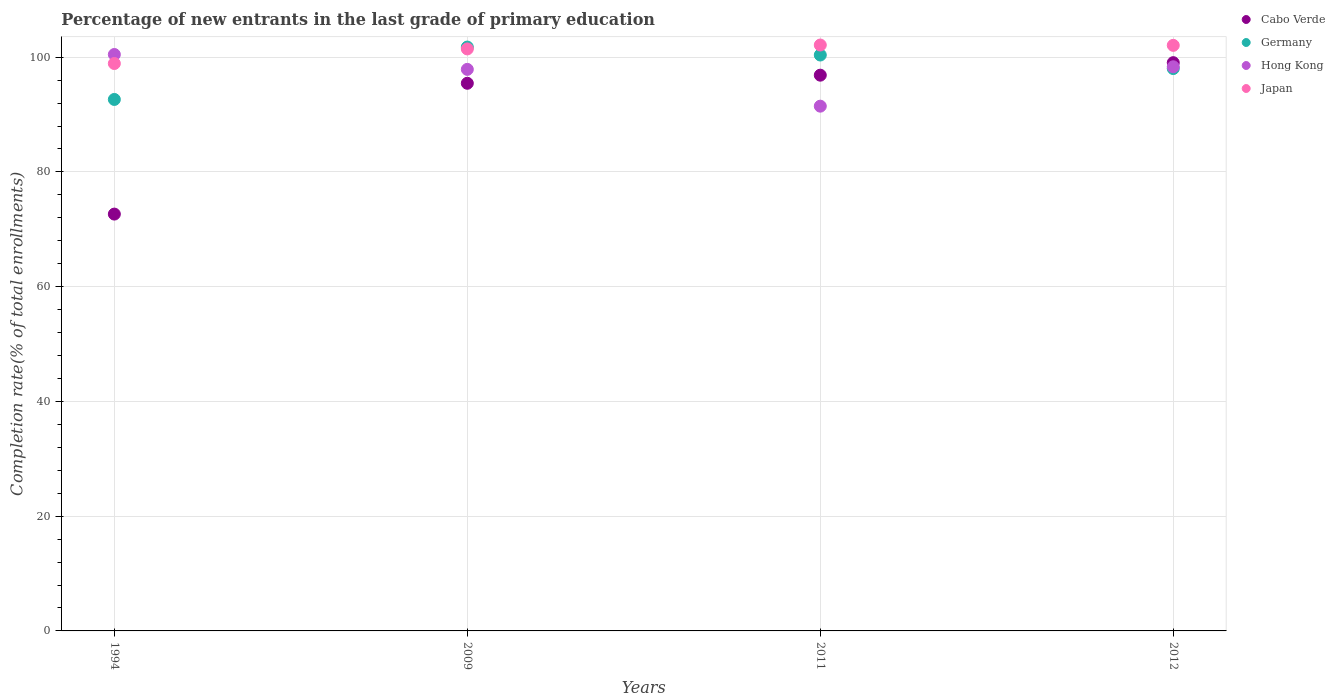Is the number of dotlines equal to the number of legend labels?
Your answer should be very brief. Yes. What is the percentage of new entrants in Germany in 2009?
Give a very brief answer. 101.76. Across all years, what is the maximum percentage of new entrants in Germany?
Your answer should be compact. 101.76. Across all years, what is the minimum percentage of new entrants in Hong Kong?
Give a very brief answer. 91.46. In which year was the percentage of new entrants in Hong Kong maximum?
Provide a succinct answer. 1994. What is the total percentage of new entrants in Cabo Verde in the graph?
Provide a succinct answer. 364. What is the difference between the percentage of new entrants in Hong Kong in 2011 and that in 2012?
Offer a very short reply. -6.86. What is the difference between the percentage of new entrants in Cabo Verde in 2011 and the percentage of new entrants in Japan in 2009?
Offer a very short reply. -4.57. What is the average percentage of new entrants in Japan per year?
Provide a short and direct response. 101.13. In the year 1994, what is the difference between the percentage of new entrants in Hong Kong and percentage of new entrants in Germany?
Your answer should be compact. 7.83. What is the ratio of the percentage of new entrants in Hong Kong in 2009 to that in 2012?
Your answer should be compact. 1. What is the difference between the highest and the second highest percentage of new entrants in Japan?
Provide a succinct answer. 0.06. What is the difference between the highest and the lowest percentage of new entrants in Germany?
Provide a succinct answer. 9.13. In how many years, is the percentage of new entrants in Cabo Verde greater than the average percentage of new entrants in Cabo Verde taken over all years?
Offer a very short reply. 3. Is the sum of the percentage of new entrants in Japan in 1994 and 2009 greater than the maximum percentage of new entrants in Hong Kong across all years?
Give a very brief answer. Yes. Does the percentage of new entrants in Germany monotonically increase over the years?
Ensure brevity in your answer.  No. How many dotlines are there?
Offer a very short reply. 4. How many years are there in the graph?
Make the answer very short. 4. Are the values on the major ticks of Y-axis written in scientific E-notation?
Your answer should be compact. No. Does the graph contain any zero values?
Ensure brevity in your answer.  No. Does the graph contain grids?
Offer a very short reply. Yes. Where does the legend appear in the graph?
Ensure brevity in your answer.  Top right. What is the title of the graph?
Ensure brevity in your answer.  Percentage of new entrants in the last grade of primary education. What is the label or title of the X-axis?
Your answer should be compact. Years. What is the label or title of the Y-axis?
Give a very brief answer. Completion rate(% of total enrollments). What is the Completion rate(% of total enrollments) of Cabo Verde in 1994?
Provide a short and direct response. 72.65. What is the Completion rate(% of total enrollments) in Germany in 1994?
Provide a short and direct response. 92.63. What is the Completion rate(% of total enrollments) in Hong Kong in 1994?
Provide a succinct answer. 100.46. What is the Completion rate(% of total enrollments) of Japan in 1994?
Ensure brevity in your answer.  98.89. What is the Completion rate(% of total enrollments) of Cabo Verde in 2009?
Your response must be concise. 95.45. What is the Completion rate(% of total enrollments) in Germany in 2009?
Ensure brevity in your answer.  101.76. What is the Completion rate(% of total enrollments) in Hong Kong in 2009?
Your answer should be very brief. 97.87. What is the Completion rate(% of total enrollments) of Japan in 2009?
Offer a very short reply. 101.44. What is the Completion rate(% of total enrollments) in Cabo Verde in 2011?
Keep it short and to the point. 96.86. What is the Completion rate(% of total enrollments) of Germany in 2011?
Provide a succinct answer. 100.37. What is the Completion rate(% of total enrollments) of Hong Kong in 2011?
Provide a succinct answer. 91.46. What is the Completion rate(% of total enrollments) in Japan in 2011?
Keep it short and to the point. 102.12. What is the Completion rate(% of total enrollments) in Cabo Verde in 2012?
Provide a succinct answer. 99.04. What is the Completion rate(% of total enrollments) in Germany in 2012?
Ensure brevity in your answer.  98.01. What is the Completion rate(% of total enrollments) of Hong Kong in 2012?
Your answer should be very brief. 98.32. What is the Completion rate(% of total enrollments) of Japan in 2012?
Ensure brevity in your answer.  102.06. Across all years, what is the maximum Completion rate(% of total enrollments) in Cabo Verde?
Offer a very short reply. 99.04. Across all years, what is the maximum Completion rate(% of total enrollments) of Germany?
Your answer should be very brief. 101.76. Across all years, what is the maximum Completion rate(% of total enrollments) in Hong Kong?
Make the answer very short. 100.46. Across all years, what is the maximum Completion rate(% of total enrollments) of Japan?
Offer a terse response. 102.12. Across all years, what is the minimum Completion rate(% of total enrollments) in Cabo Verde?
Your response must be concise. 72.65. Across all years, what is the minimum Completion rate(% of total enrollments) in Germany?
Keep it short and to the point. 92.63. Across all years, what is the minimum Completion rate(% of total enrollments) of Hong Kong?
Your answer should be very brief. 91.46. Across all years, what is the minimum Completion rate(% of total enrollments) of Japan?
Provide a succinct answer. 98.89. What is the total Completion rate(% of total enrollments) of Cabo Verde in the graph?
Give a very brief answer. 364. What is the total Completion rate(% of total enrollments) in Germany in the graph?
Provide a short and direct response. 392.78. What is the total Completion rate(% of total enrollments) of Hong Kong in the graph?
Offer a terse response. 388.12. What is the total Completion rate(% of total enrollments) in Japan in the graph?
Give a very brief answer. 404.5. What is the difference between the Completion rate(% of total enrollments) in Cabo Verde in 1994 and that in 2009?
Keep it short and to the point. -22.8. What is the difference between the Completion rate(% of total enrollments) in Germany in 1994 and that in 2009?
Provide a short and direct response. -9.13. What is the difference between the Completion rate(% of total enrollments) in Hong Kong in 1994 and that in 2009?
Give a very brief answer. 2.59. What is the difference between the Completion rate(% of total enrollments) of Japan in 1994 and that in 2009?
Provide a succinct answer. -2.54. What is the difference between the Completion rate(% of total enrollments) of Cabo Verde in 1994 and that in 2011?
Ensure brevity in your answer.  -24.21. What is the difference between the Completion rate(% of total enrollments) in Germany in 1994 and that in 2011?
Make the answer very short. -7.74. What is the difference between the Completion rate(% of total enrollments) in Hong Kong in 1994 and that in 2011?
Your response must be concise. 9.01. What is the difference between the Completion rate(% of total enrollments) in Japan in 1994 and that in 2011?
Your response must be concise. -3.22. What is the difference between the Completion rate(% of total enrollments) in Cabo Verde in 1994 and that in 2012?
Your response must be concise. -26.39. What is the difference between the Completion rate(% of total enrollments) of Germany in 1994 and that in 2012?
Your response must be concise. -5.38. What is the difference between the Completion rate(% of total enrollments) in Hong Kong in 1994 and that in 2012?
Your response must be concise. 2.14. What is the difference between the Completion rate(% of total enrollments) of Japan in 1994 and that in 2012?
Provide a succinct answer. -3.16. What is the difference between the Completion rate(% of total enrollments) of Cabo Verde in 2009 and that in 2011?
Keep it short and to the point. -1.41. What is the difference between the Completion rate(% of total enrollments) of Germany in 2009 and that in 2011?
Make the answer very short. 1.38. What is the difference between the Completion rate(% of total enrollments) in Hong Kong in 2009 and that in 2011?
Your response must be concise. 6.41. What is the difference between the Completion rate(% of total enrollments) in Japan in 2009 and that in 2011?
Make the answer very short. -0.68. What is the difference between the Completion rate(% of total enrollments) in Cabo Verde in 2009 and that in 2012?
Provide a succinct answer. -3.59. What is the difference between the Completion rate(% of total enrollments) of Germany in 2009 and that in 2012?
Ensure brevity in your answer.  3.75. What is the difference between the Completion rate(% of total enrollments) in Hong Kong in 2009 and that in 2012?
Your response must be concise. -0.45. What is the difference between the Completion rate(% of total enrollments) of Japan in 2009 and that in 2012?
Your response must be concise. -0.62. What is the difference between the Completion rate(% of total enrollments) in Cabo Verde in 2011 and that in 2012?
Your answer should be very brief. -2.18. What is the difference between the Completion rate(% of total enrollments) in Germany in 2011 and that in 2012?
Your response must be concise. 2.36. What is the difference between the Completion rate(% of total enrollments) of Hong Kong in 2011 and that in 2012?
Your answer should be very brief. -6.86. What is the difference between the Completion rate(% of total enrollments) of Japan in 2011 and that in 2012?
Give a very brief answer. 0.06. What is the difference between the Completion rate(% of total enrollments) of Cabo Verde in 1994 and the Completion rate(% of total enrollments) of Germany in 2009?
Your answer should be very brief. -29.11. What is the difference between the Completion rate(% of total enrollments) of Cabo Verde in 1994 and the Completion rate(% of total enrollments) of Hong Kong in 2009?
Your answer should be very brief. -25.22. What is the difference between the Completion rate(% of total enrollments) in Cabo Verde in 1994 and the Completion rate(% of total enrollments) in Japan in 2009?
Provide a succinct answer. -28.79. What is the difference between the Completion rate(% of total enrollments) in Germany in 1994 and the Completion rate(% of total enrollments) in Hong Kong in 2009?
Your answer should be compact. -5.24. What is the difference between the Completion rate(% of total enrollments) in Germany in 1994 and the Completion rate(% of total enrollments) in Japan in 2009?
Provide a short and direct response. -8.81. What is the difference between the Completion rate(% of total enrollments) of Hong Kong in 1994 and the Completion rate(% of total enrollments) of Japan in 2009?
Keep it short and to the point. -0.97. What is the difference between the Completion rate(% of total enrollments) in Cabo Verde in 1994 and the Completion rate(% of total enrollments) in Germany in 2011?
Your response must be concise. -27.73. What is the difference between the Completion rate(% of total enrollments) of Cabo Verde in 1994 and the Completion rate(% of total enrollments) of Hong Kong in 2011?
Provide a succinct answer. -18.81. What is the difference between the Completion rate(% of total enrollments) in Cabo Verde in 1994 and the Completion rate(% of total enrollments) in Japan in 2011?
Your answer should be compact. -29.47. What is the difference between the Completion rate(% of total enrollments) in Germany in 1994 and the Completion rate(% of total enrollments) in Hong Kong in 2011?
Ensure brevity in your answer.  1.17. What is the difference between the Completion rate(% of total enrollments) of Germany in 1994 and the Completion rate(% of total enrollments) of Japan in 2011?
Your answer should be compact. -9.49. What is the difference between the Completion rate(% of total enrollments) in Hong Kong in 1994 and the Completion rate(% of total enrollments) in Japan in 2011?
Your answer should be compact. -1.65. What is the difference between the Completion rate(% of total enrollments) in Cabo Verde in 1994 and the Completion rate(% of total enrollments) in Germany in 2012?
Offer a terse response. -25.36. What is the difference between the Completion rate(% of total enrollments) in Cabo Verde in 1994 and the Completion rate(% of total enrollments) in Hong Kong in 2012?
Offer a terse response. -25.67. What is the difference between the Completion rate(% of total enrollments) in Cabo Verde in 1994 and the Completion rate(% of total enrollments) in Japan in 2012?
Provide a succinct answer. -29.41. What is the difference between the Completion rate(% of total enrollments) in Germany in 1994 and the Completion rate(% of total enrollments) in Hong Kong in 2012?
Ensure brevity in your answer.  -5.69. What is the difference between the Completion rate(% of total enrollments) of Germany in 1994 and the Completion rate(% of total enrollments) of Japan in 2012?
Provide a succinct answer. -9.43. What is the difference between the Completion rate(% of total enrollments) in Hong Kong in 1994 and the Completion rate(% of total enrollments) in Japan in 2012?
Your response must be concise. -1.59. What is the difference between the Completion rate(% of total enrollments) in Cabo Verde in 2009 and the Completion rate(% of total enrollments) in Germany in 2011?
Ensure brevity in your answer.  -4.92. What is the difference between the Completion rate(% of total enrollments) of Cabo Verde in 2009 and the Completion rate(% of total enrollments) of Hong Kong in 2011?
Your answer should be compact. 3.99. What is the difference between the Completion rate(% of total enrollments) of Cabo Verde in 2009 and the Completion rate(% of total enrollments) of Japan in 2011?
Keep it short and to the point. -6.67. What is the difference between the Completion rate(% of total enrollments) of Germany in 2009 and the Completion rate(% of total enrollments) of Hong Kong in 2011?
Make the answer very short. 10.3. What is the difference between the Completion rate(% of total enrollments) in Germany in 2009 and the Completion rate(% of total enrollments) in Japan in 2011?
Keep it short and to the point. -0.36. What is the difference between the Completion rate(% of total enrollments) of Hong Kong in 2009 and the Completion rate(% of total enrollments) of Japan in 2011?
Offer a terse response. -4.24. What is the difference between the Completion rate(% of total enrollments) in Cabo Verde in 2009 and the Completion rate(% of total enrollments) in Germany in 2012?
Make the answer very short. -2.56. What is the difference between the Completion rate(% of total enrollments) of Cabo Verde in 2009 and the Completion rate(% of total enrollments) of Hong Kong in 2012?
Offer a very short reply. -2.87. What is the difference between the Completion rate(% of total enrollments) of Cabo Verde in 2009 and the Completion rate(% of total enrollments) of Japan in 2012?
Give a very brief answer. -6.61. What is the difference between the Completion rate(% of total enrollments) of Germany in 2009 and the Completion rate(% of total enrollments) of Hong Kong in 2012?
Provide a succinct answer. 3.44. What is the difference between the Completion rate(% of total enrollments) in Germany in 2009 and the Completion rate(% of total enrollments) in Japan in 2012?
Provide a succinct answer. -0.3. What is the difference between the Completion rate(% of total enrollments) of Hong Kong in 2009 and the Completion rate(% of total enrollments) of Japan in 2012?
Provide a short and direct response. -4.19. What is the difference between the Completion rate(% of total enrollments) in Cabo Verde in 2011 and the Completion rate(% of total enrollments) in Germany in 2012?
Provide a short and direct response. -1.15. What is the difference between the Completion rate(% of total enrollments) in Cabo Verde in 2011 and the Completion rate(% of total enrollments) in Hong Kong in 2012?
Offer a very short reply. -1.46. What is the difference between the Completion rate(% of total enrollments) of Cabo Verde in 2011 and the Completion rate(% of total enrollments) of Japan in 2012?
Make the answer very short. -5.2. What is the difference between the Completion rate(% of total enrollments) of Germany in 2011 and the Completion rate(% of total enrollments) of Hong Kong in 2012?
Offer a very short reply. 2.05. What is the difference between the Completion rate(% of total enrollments) of Germany in 2011 and the Completion rate(% of total enrollments) of Japan in 2012?
Your answer should be very brief. -1.68. What is the difference between the Completion rate(% of total enrollments) in Hong Kong in 2011 and the Completion rate(% of total enrollments) in Japan in 2012?
Make the answer very short. -10.6. What is the average Completion rate(% of total enrollments) in Cabo Verde per year?
Your answer should be compact. 91. What is the average Completion rate(% of total enrollments) in Germany per year?
Provide a short and direct response. 98.19. What is the average Completion rate(% of total enrollments) of Hong Kong per year?
Your response must be concise. 97.03. What is the average Completion rate(% of total enrollments) in Japan per year?
Ensure brevity in your answer.  101.13. In the year 1994, what is the difference between the Completion rate(% of total enrollments) of Cabo Verde and Completion rate(% of total enrollments) of Germany?
Keep it short and to the point. -19.98. In the year 1994, what is the difference between the Completion rate(% of total enrollments) in Cabo Verde and Completion rate(% of total enrollments) in Hong Kong?
Ensure brevity in your answer.  -27.82. In the year 1994, what is the difference between the Completion rate(% of total enrollments) of Cabo Verde and Completion rate(% of total enrollments) of Japan?
Your answer should be compact. -26.24. In the year 1994, what is the difference between the Completion rate(% of total enrollments) of Germany and Completion rate(% of total enrollments) of Hong Kong?
Your answer should be compact. -7.83. In the year 1994, what is the difference between the Completion rate(% of total enrollments) in Germany and Completion rate(% of total enrollments) in Japan?
Offer a terse response. -6.26. In the year 1994, what is the difference between the Completion rate(% of total enrollments) in Hong Kong and Completion rate(% of total enrollments) in Japan?
Make the answer very short. 1.57. In the year 2009, what is the difference between the Completion rate(% of total enrollments) of Cabo Verde and Completion rate(% of total enrollments) of Germany?
Provide a succinct answer. -6.31. In the year 2009, what is the difference between the Completion rate(% of total enrollments) of Cabo Verde and Completion rate(% of total enrollments) of Hong Kong?
Provide a short and direct response. -2.42. In the year 2009, what is the difference between the Completion rate(% of total enrollments) of Cabo Verde and Completion rate(% of total enrollments) of Japan?
Give a very brief answer. -5.99. In the year 2009, what is the difference between the Completion rate(% of total enrollments) in Germany and Completion rate(% of total enrollments) in Hong Kong?
Your response must be concise. 3.89. In the year 2009, what is the difference between the Completion rate(% of total enrollments) of Germany and Completion rate(% of total enrollments) of Japan?
Ensure brevity in your answer.  0.32. In the year 2009, what is the difference between the Completion rate(% of total enrollments) of Hong Kong and Completion rate(% of total enrollments) of Japan?
Offer a very short reply. -3.56. In the year 2011, what is the difference between the Completion rate(% of total enrollments) of Cabo Verde and Completion rate(% of total enrollments) of Germany?
Give a very brief answer. -3.51. In the year 2011, what is the difference between the Completion rate(% of total enrollments) in Cabo Verde and Completion rate(% of total enrollments) in Hong Kong?
Your response must be concise. 5.4. In the year 2011, what is the difference between the Completion rate(% of total enrollments) of Cabo Verde and Completion rate(% of total enrollments) of Japan?
Your answer should be very brief. -5.25. In the year 2011, what is the difference between the Completion rate(% of total enrollments) of Germany and Completion rate(% of total enrollments) of Hong Kong?
Your response must be concise. 8.92. In the year 2011, what is the difference between the Completion rate(% of total enrollments) of Germany and Completion rate(% of total enrollments) of Japan?
Offer a very short reply. -1.74. In the year 2011, what is the difference between the Completion rate(% of total enrollments) in Hong Kong and Completion rate(% of total enrollments) in Japan?
Your answer should be very brief. -10.66. In the year 2012, what is the difference between the Completion rate(% of total enrollments) in Cabo Verde and Completion rate(% of total enrollments) in Germany?
Your answer should be very brief. 1.03. In the year 2012, what is the difference between the Completion rate(% of total enrollments) of Cabo Verde and Completion rate(% of total enrollments) of Hong Kong?
Provide a succinct answer. 0.72. In the year 2012, what is the difference between the Completion rate(% of total enrollments) in Cabo Verde and Completion rate(% of total enrollments) in Japan?
Offer a terse response. -3.02. In the year 2012, what is the difference between the Completion rate(% of total enrollments) of Germany and Completion rate(% of total enrollments) of Hong Kong?
Your response must be concise. -0.31. In the year 2012, what is the difference between the Completion rate(% of total enrollments) of Germany and Completion rate(% of total enrollments) of Japan?
Provide a short and direct response. -4.04. In the year 2012, what is the difference between the Completion rate(% of total enrollments) of Hong Kong and Completion rate(% of total enrollments) of Japan?
Your answer should be very brief. -3.73. What is the ratio of the Completion rate(% of total enrollments) in Cabo Verde in 1994 to that in 2009?
Provide a short and direct response. 0.76. What is the ratio of the Completion rate(% of total enrollments) of Germany in 1994 to that in 2009?
Offer a terse response. 0.91. What is the ratio of the Completion rate(% of total enrollments) in Hong Kong in 1994 to that in 2009?
Provide a succinct answer. 1.03. What is the ratio of the Completion rate(% of total enrollments) in Japan in 1994 to that in 2009?
Ensure brevity in your answer.  0.97. What is the ratio of the Completion rate(% of total enrollments) of Cabo Verde in 1994 to that in 2011?
Ensure brevity in your answer.  0.75. What is the ratio of the Completion rate(% of total enrollments) of Germany in 1994 to that in 2011?
Your answer should be compact. 0.92. What is the ratio of the Completion rate(% of total enrollments) in Hong Kong in 1994 to that in 2011?
Give a very brief answer. 1.1. What is the ratio of the Completion rate(% of total enrollments) in Japan in 1994 to that in 2011?
Provide a succinct answer. 0.97. What is the ratio of the Completion rate(% of total enrollments) of Cabo Verde in 1994 to that in 2012?
Offer a very short reply. 0.73. What is the ratio of the Completion rate(% of total enrollments) of Germany in 1994 to that in 2012?
Your answer should be very brief. 0.95. What is the ratio of the Completion rate(% of total enrollments) in Hong Kong in 1994 to that in 2012?
Offer a terse response. 1.02. What is the ratio of the Completion rate(% of total enrollments) in Japan in 1994 to that in 2012?
Offer a terse response. 0.97. What is the ratio of the Completion rate(% of total enrollments) of Cabo Verde in 2009 to that in 2011?
Your answer should be very brief. 0.99. What is the ratio of the Completion rate(% of total enrollments) in Germany in 2009 to that in 2011?
Provide a succinct answer. 1.01. What is the ratio of the Completion rate(% of total enrollments) in Hong Kong in 2009 to that in 2011?
Your answer should be very brief. 1.07. What is the ratio of the Completion rate(% of total enrollments) in Cabo Verde in 2009 to that in 2012?
Provide a succinct answer. 0.96. What is the ratio of the Completion rate(% of total enrollments) in Germany in 2009 to that in 2012?
Offer a very short reply. 1.04. What is the ratio of the Completion rate(% of total enrollments) in Japan in 2009 to that in 2012?
Provide a short and direct response. 0.99. What is the ratio of the Completion rate(% of total enrollments) in Germany in 2011 to that in 2012?
Make the answer very short. 1.02. What is the ratio of the Completion rate(% of total enrollments) of Hong Kong in 2011 to that in 2012?
Give a very brief answer. 0.93. What is the difference between the highest and the second highest Completion rate(% of total enrollments) in Cabo Verde?
Ensure brevity in your answer.  2.18. What is the difference between the highest and the second highest Completion rate(% of total enrollments) in Germany?
Ensure brevity in your answer.  1.38. What is the difference between the highest and the second highest Completion rate(% of total enrollments) in Hong Kong?
Make the answer very short. 2.14. What is the difference between the highest and the second highest Completion rate(% of total enrollments) in Japan?
Ensure brevity in your answer.  0.06. What is the difference between the highest and the lowest Completion rate(% of total enrollments) in Cabo Verde?
Ensure brevity in your answer.  26.39. What is the difference between the highest and the lowest Completion rate(% of total enrollments) in Germany?
Give a very brief answer. 9.13. What is the difference between the highest and the lowest Completion rate(% of total enrollments) in Hong Kong?
Provide a short and direct response. 9.01. What is the difference between the highest and the lowest Completion rate(% of total enrollments) of Japan?
Keep it short and to the point. 3.22. 